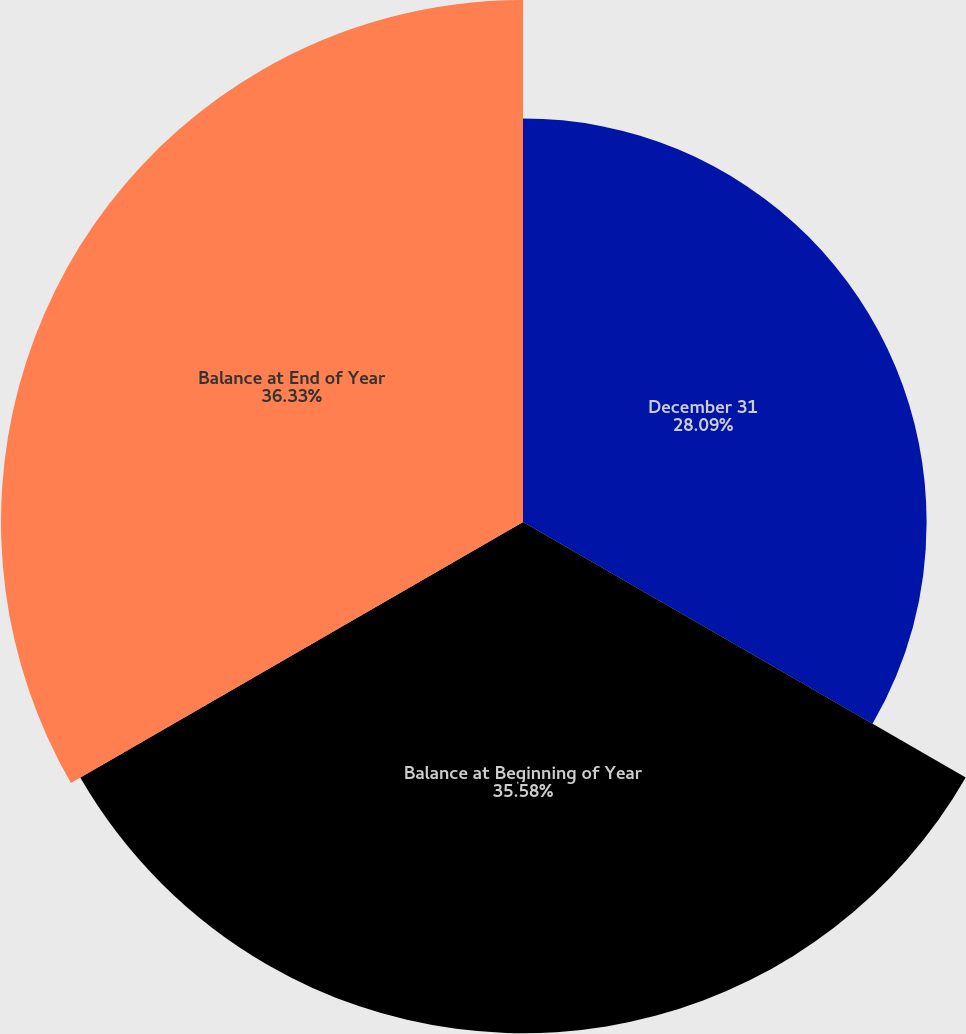<chart> <loc_0><loc_0><loc_500><loc_500><pie_chart><fcel>December 31<fcel>Balance at Beginning of Year<fcel>Balance at End of Year<nl><fcel>28.09%<fcel>35.58%<fcel>36.33%<nl></chart> 